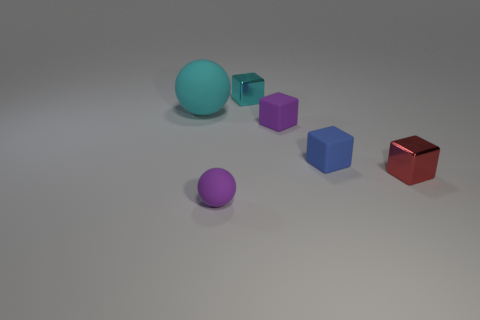Subtract all cyan shiny blocks. How many blocks are left? 3 Add 2 yellow balls. How many objects exist? 8 Subtract 2 balls. How many balls are left? 0 Subtract all purple balls. How many balls are left? 1 Add 2 tiny purple balls. How many tiny purple balls exist? 3 Subtract 0 gray cylinders. How many objects are left? 6 Subtract all cubes. How many objects are left? 2 Subtract all cyan spheres. Subtract all gray cylinders. How many spheres are left? 1 Subtract all cyan matte things. Subtract all shiny blocks. How many objects are left? 3 Add 2 tiny balls. How many tiny balls are left? 3 